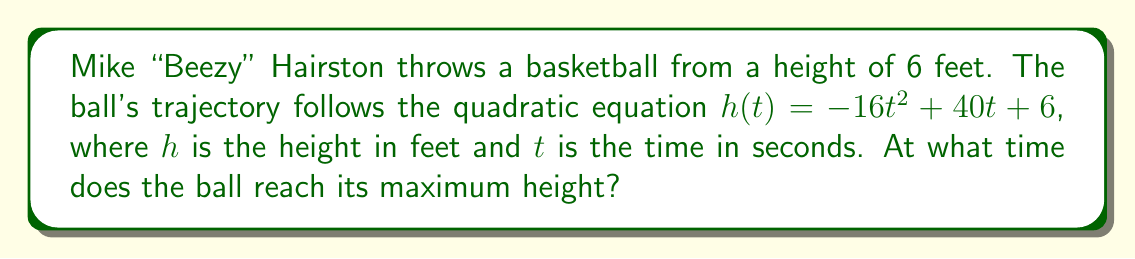Teach me how to tackle this problem. To find the time when the ball reaches its maximum height, we need to follow these steps:

1) The quadratic equation representing the ball's trajectory is:
   $h(t) = -16t^2 + 40t + 6$

2) In a quadratic function $f(x) = ax^2 + bx + c$, the x-coordinate of the vertex (which represents the maximum or minimum point) is given by the formula $x = -\frac{b}{2a}$

3) In our case, $a = -16$ and $b = 40$. Let's substitute these values:

   $t = -\frac{40}{2(-16)} = -\frac{40}{-32} = \frac{40}{32} = \frac{5}{4} = 1.25$

4) Therefore, the ball reaches its maximum height at $t = 1.25$ seconds after Beezy throws it.

5) We can verify this by calculating the height at this time:
   $h(1.25) = -16(1.25)^2 + 40(1.25) + 6$
             $= -16(1.5625) + 50 + 6$
             $= -25 + 50 + 6$
             $= 31$ feet

This is indeed the maximum height the ball reaches.
Answer: 1.25 seconds 